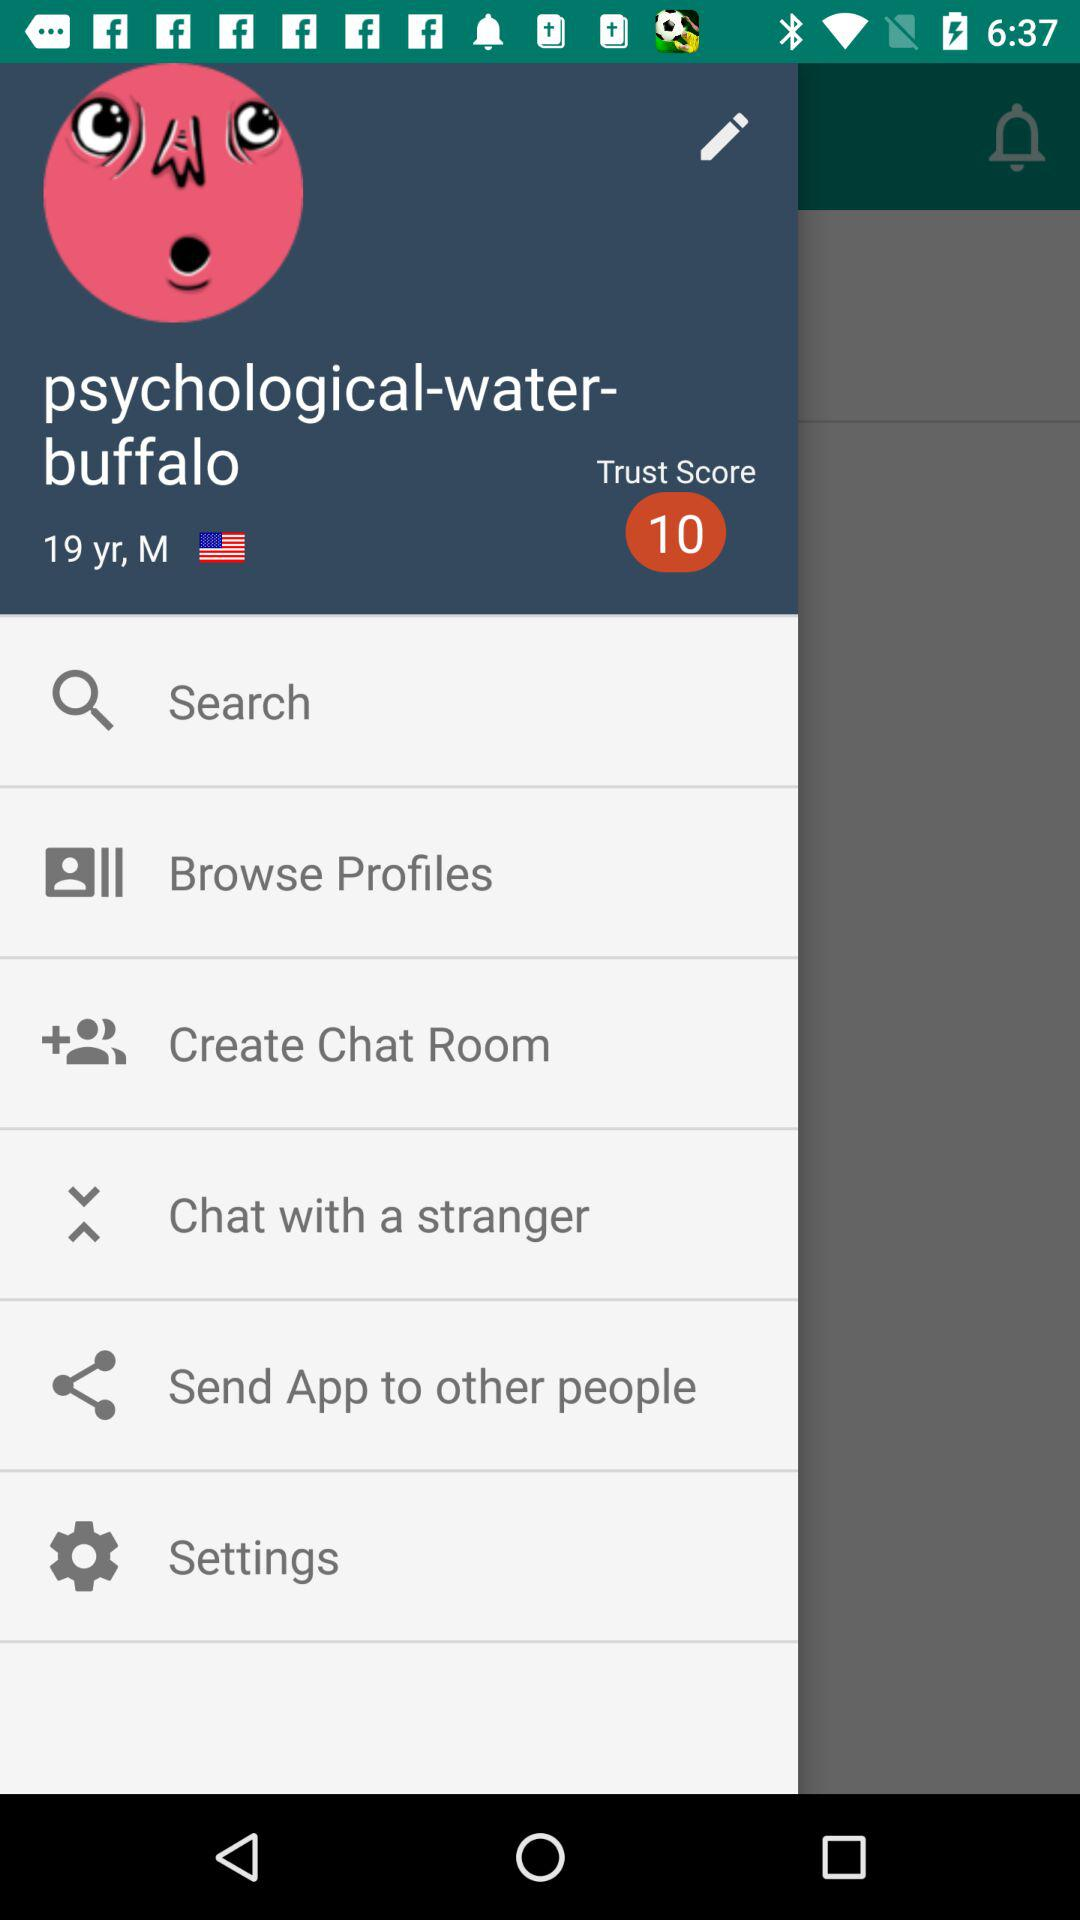What is the "Trust Score"? The "Trust Score" is 10. 